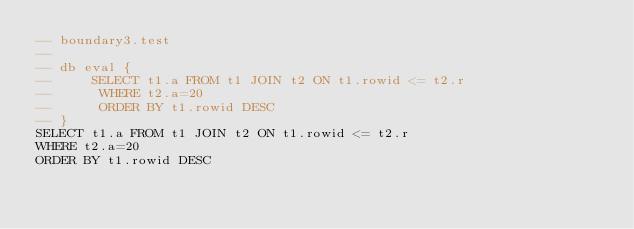Convert code to text. <code><loc_0><loc_0><loc_500><loc_500><_SQL_>-- boundary3.test
-- 
-- db eval {
--     SELECT t1.a FROM t1 JOIN t2 ON t1.rowid <= t2.r
--      WHERE t2.a=20
--      ORDER BY t1.rowid DESC
-- }
SELECT t1.a FROM t1 JOIN t2 ON t1.rowid <= t2.r
WHERE t2.a=20
ORDER BY t1.rowid DESC</code> 